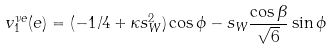Convert formula to latex. <formula><loc_0><loc_0><loc_500><loc_500>v _ { 1 } ^ { \nu e } ( e ) = ( - 1 / 4 + \kappa s _ { W } ^ { 2 } ) \cos \phi - s _ { W } \frac { \cos \beta } { \sqrt { 6 } } \sin \phi</formula> 